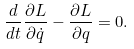<formula> <loc_0><loc_0><loc_500><loc_500>\frac { d } { d t } \frac { \partial L } { \partial \dot { q } } - \frac { \partial L } { \partial q } = 0 .</formula> 